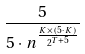Convert formula to latex. <formula><loc_0><loc_0><loc_500><loc_500>\frac { 5 } { 5 \cdot n ^ { \frac { K \times ( 5 \cdot K ) } { 2 ^ { T + 5 } } } }</formula> 